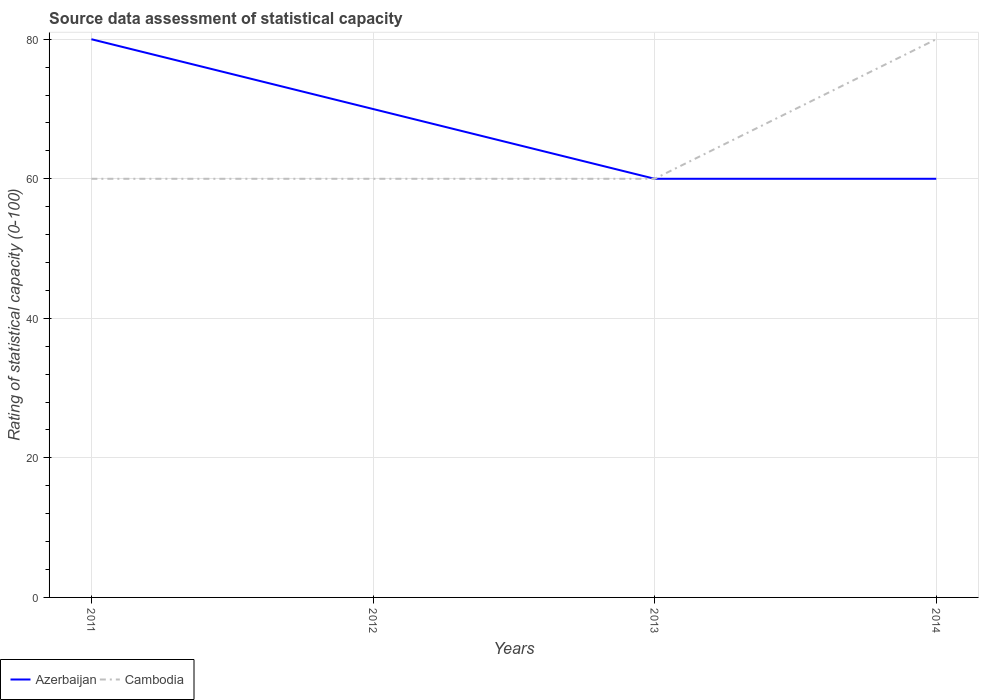Across all years, what is the maximum rating of statistical capacity in Azerbaijan?
Keep it short and to the point. 60. What is the total rating of statistical capacity in Cambodia in the graph?
Make the answer very short. -20. What is the difference between the highest and the second highest rating of statistical capacity in Cambodia?
Offer a terse response. 20. What is the difference between the highest and the lowest rating of statistical capacity in Azerbaijan?
Ensure brevity in your answer.  2. Are the values on the major ticks of Y-axis written in scientific E-notation?
Provide a succinct answer. No. Where does the legend appear in the graph?
Offer a very short reply. Bottom left. What is the title of the graph?
Your response must be concise. Source data assessment of statistical capacity. What is the label or title of the Y-axis?
Give a very brief answer. Rating of statistical capacity (0-100). What is the Rating of statistical capacity (0-100) in Azerbaijan in 2011?
Provide a short and direct response. 80. What is the Rating of statistical capacity (0-100) of Azerbaijan in 2012?
Your answer should be compact. 70. What is the Rating of statistical capacity (0-100) in Azerbaijan in 2013?
Offer a very short reply. 60. What is the Rating of statistical capacity (0-100) in Cambodia in 2014?
Make the answer very short. 80. Across all years, what is the maximum Rating of statistical capacity (0-100) in Azerbaijan?
Provide a succinct answer. 80. Across all years, what is the maximum Rating of statistical capacity (0-100) of Cambodia?
Offer a very short reply. 80. Across all years, what is the minimum Rating of statistical capacity (0-100) in Cambodia?
Make the answer very short. 60. What is the total Rating of statistical capacity (0-100) in Azerbaijan in the graph?
Make the answer very short. 270. What is the total Rating of statistical capacity (0-100) in Cambodia in the graph?
Your response must be concise. 260. What is the difference between the Rating of statistical capacity (0-100) in Cambodia in 2011 and that in 2012?
Ensure brevity in your answer.  0. What is the difference between the Rating of statistical capacity (0-100) in Azerbaijan in 2011 and that in 2013?
Your answer should be very brief. 20. What is the difference between the Rating of statistical capacity (0-100) in Cambodia in 2011 and that in 2014?
Give a very brief answer. -20. What is the difference between the Rating of statistical capacity (0-100) of Cambodia in 2012 and that in 2013?
Your answer should be very brief. 0. What is the difference between the Rating of statistical capacity (0-100) in Cambodia in 2012 and that in 2014?
Your response must be concise. -20. What is the difference between the Rating of statistical capacity (0-100) of Cambodia in 2013 and that in 2014?
Offer a terse response. -20. What is the difference between the Rating of statistical capacity (0-100) in Azerbaijan in 2012 and the Rating of statistical capacity (0-100) in Cambodia in 2014?
Your response must be concise. -10. What is the average Rating of statistical capacity (0-100) in Azerbaijan per year?
Your answer should be compact. 67.5. What is the average Rating of statistical capacity (0-100) of Cambodia per year?
Give a very brief answer. 65. What is the ratio of the Rating of statistical capacity (0-100) of Azerbaijan in 2011 to that in 2012?
Provide a succinct answer. 1.14. What is the ratio of the Rating of statistical capacity (0-100) in Cambodia in 2011 to that in 2012?
Offer a terse response. 1. What is the ratio of the Rating of statistical capacity (0-100) of Azerbaijan in 2011 to that in 2014?
Offer a very short reply. 1.33. What is the ratio of the Rating of statistical capacity (0-100) of Cambodia in 2011 to that in 2014?
Make the answer very short. 0.75. What is the ratio of the Rating of statistical capacity (0-100) of Azerbaijan in 2012 to that in 2013?
Provide a succinct answer. 1.17. What is the ratio of the Rating of statistical capacity (0-100) in Azerbaijan in 2012 to that in 2014?
Your answer should be very brief. 1.17. What is the ratio of the Rating of statistical capacity (0-100) in Cambodia in 2012 to that in 2014?
Ensure brevity in your answer.  0.75. What is the difference between the highest and the second highest Rating of statistical capacity (0-100) of Cambodia?
Your answer should be compact. 20. What is the difference between the highest and the lowest Rating of statistical capacity (0-100) of Azerbaijan?
Offer a terse response. 20. 